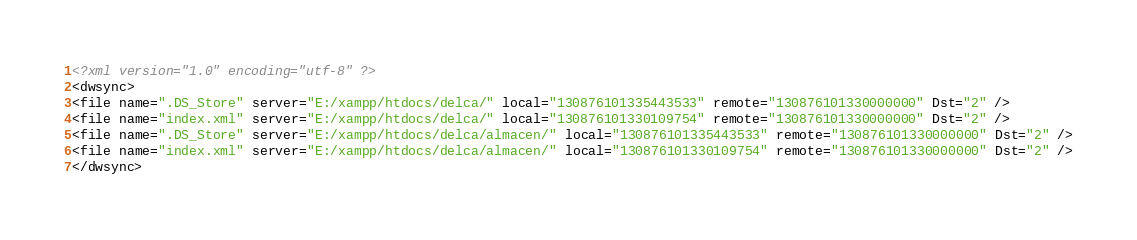Convert code to text. <code><loc_0><loc_0><loc_500><loc_500><_XML_><?xml version="1.0" encoding="utf-8" ?>
<dwsync>
<file name=".DS_Store" server="E:/xampp/htdocs/delca/" local="130876101335443533" remote="130876101330000000" Dst="2" />
<file name="index.xml" server="E:/xampp/htdocs/delca/" local="130876101330109754" remote="130876101330000000" Dst="2" />
<file name=".DS_Store" server="E:/xampp/htdocs/delca/almacen/" local="130876101335443533" remote="130876101330000000" Dst="2" />
<file name="index.xml" server="E:/xampp/htdocs/delca/almacen/" local="130876101330109754" remote="130876101330000000" Dst="2" />
</dwsync></code> 